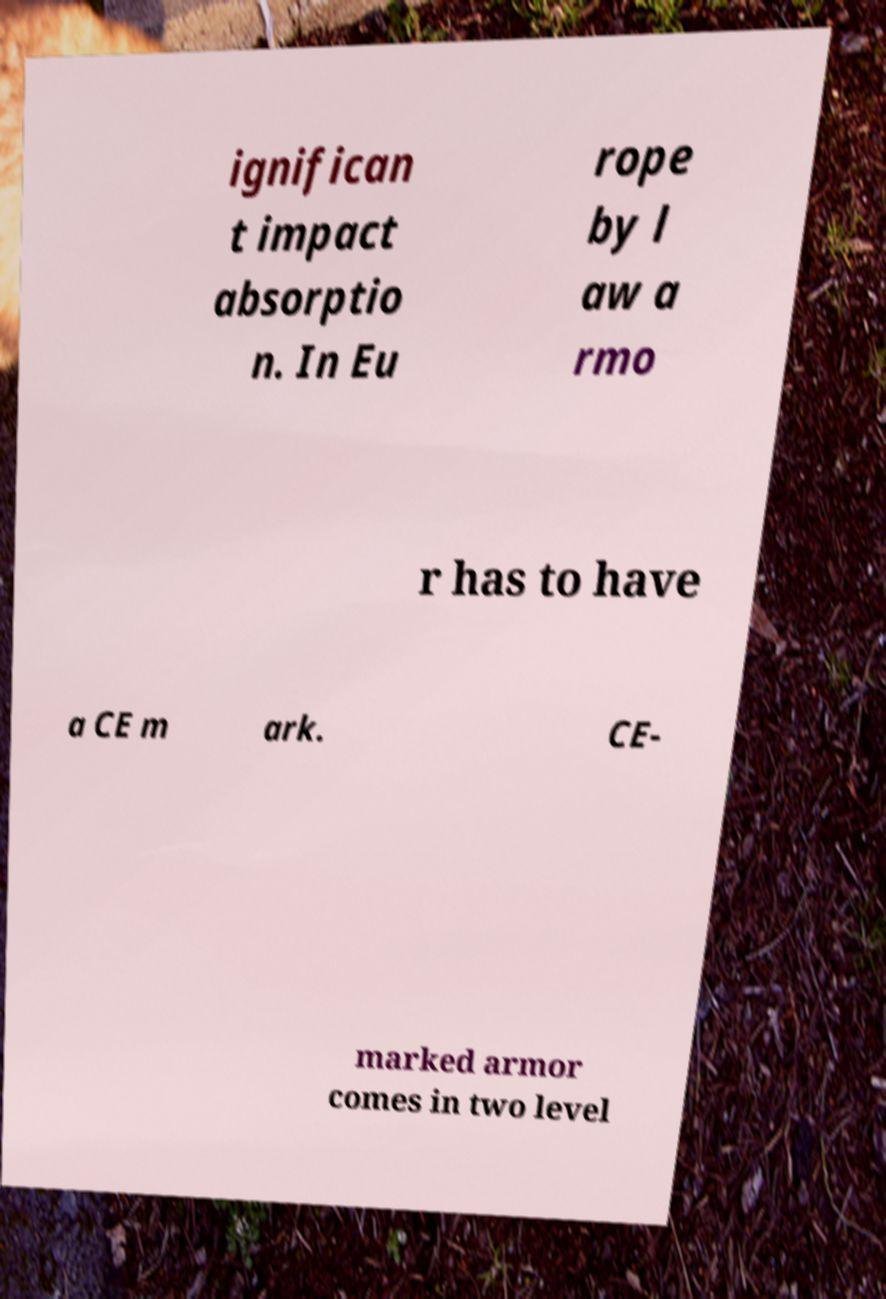Could you assist in decoding the text presented in this image and type it out clearly? ignifican t impact absorptio n. In Eu rope by l aw a rmo r has to have a CE m ark. CE- marked armor comes in two level 